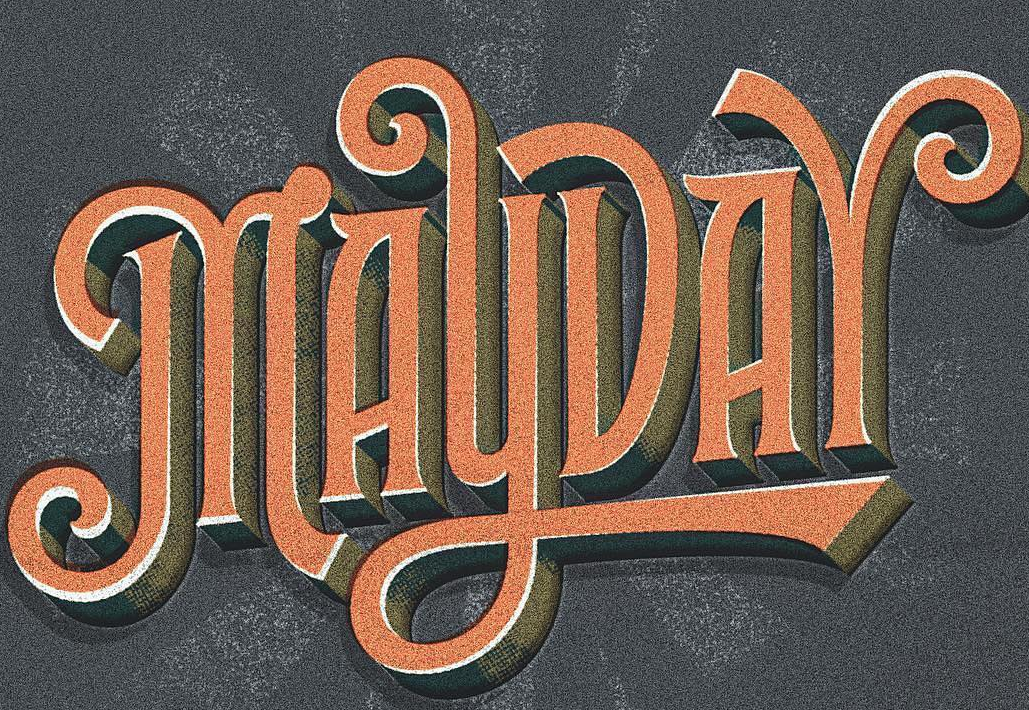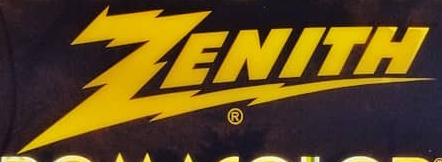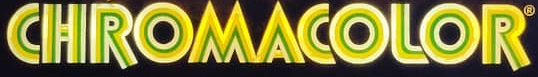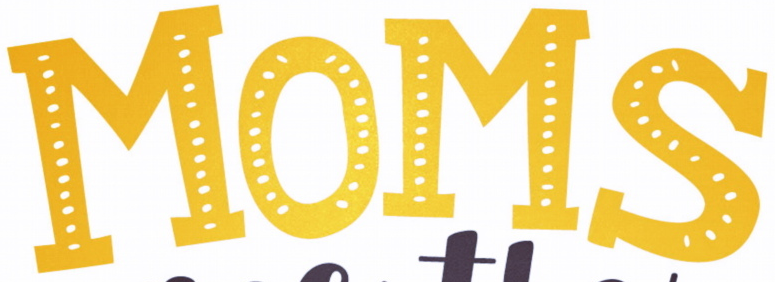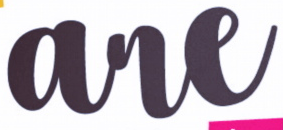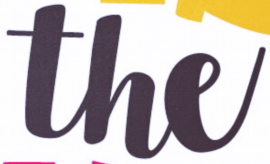What words are shown in these images in order, separated by a semicolon? MAYDAY; ZENITH; CHROMACOLOR; MOMS; are; the 